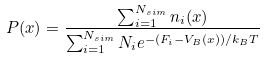Convert formula to latex. <formula><loc_0><loc_0><loc_500><loc_500>P ( x ) = \frac { \sum _ { i = 1 } ^ { N _ { s i m } } n _ { i } ( x ) } { \sum _ { i = 1 } ^ { N _ { s i m } } N _ { i } e ^ { - ( F _ { i } - V _ { B } ( x ) ) / k _ { B } T } }</formula> 